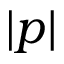Convert formula to latex. <formula><loc_0><loc_0><loc_500><loc_500>| p |</formula> 